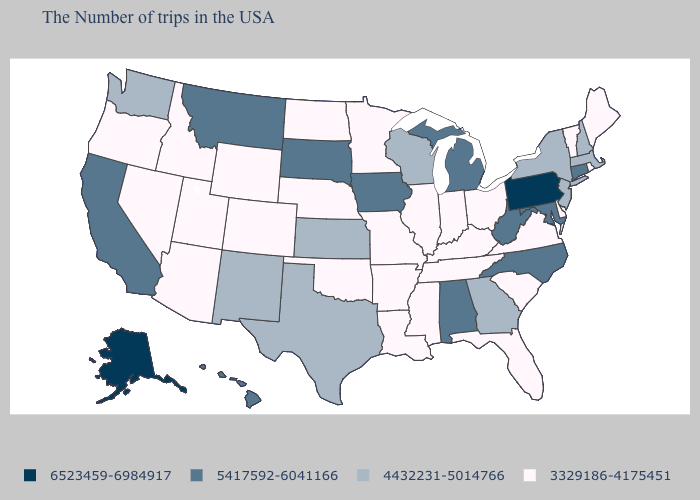What is the lowest value in the MidWest?
Keep it brief. 3329186-4175451. Does Iowa have the highest value in the MidWest?
Be succinct. Yes. What is the value of Montana?
Concise answer only. 5417592-6041166. Name the states that have a value in the range 3329186-4175451?
Concise answer only. Maine, Rhode Island, Vermont, Delaware, Virginia, South Carolina, Ohio, Florida, Kentucky, Indiana, Tennessee, Illinois, Mississippi, Louisiana, Missouri, Arkansas, Minnesota, Nebraska, Oklahoma, North Dakota, Wyoming, Colorado, Utah, Arizona, Idaho, Nevada, Oregon. Which states have the highest value in the USA?
Concise answer only. Pennsylvania, Alaska. What is the value of Maine?
Write a very short answer. 3329186-4175451. Does Nevada have the same value as Minnesota?
Write a very short answer. Yes. What is the lowest value in states that border Michigan?
Short answer required. 3329186-4175451. Name the states that have a value in the range 4432231-5014766?
Short answer required. Massachusetts, New Hampshire, New York, New Jersey, Georgia, Wisconsin, Kansas, Texas, New Mexico, Washington. Does the map have missing data?
Give a very brief answer. No. What is the highest value in states that border Wyoming?
Concise answer only. 5417592-6041166. Does the first symbol in the legend represent the smallest category?
Quick response, please. No. Does Georgia have a higher value than Idaho?
Concise answer only. Yes. Does Ohio have the highest value in the USA?
Short answer required. No. Does New Hampshire have a higher value than Maryland?
Answer briefly. No. 